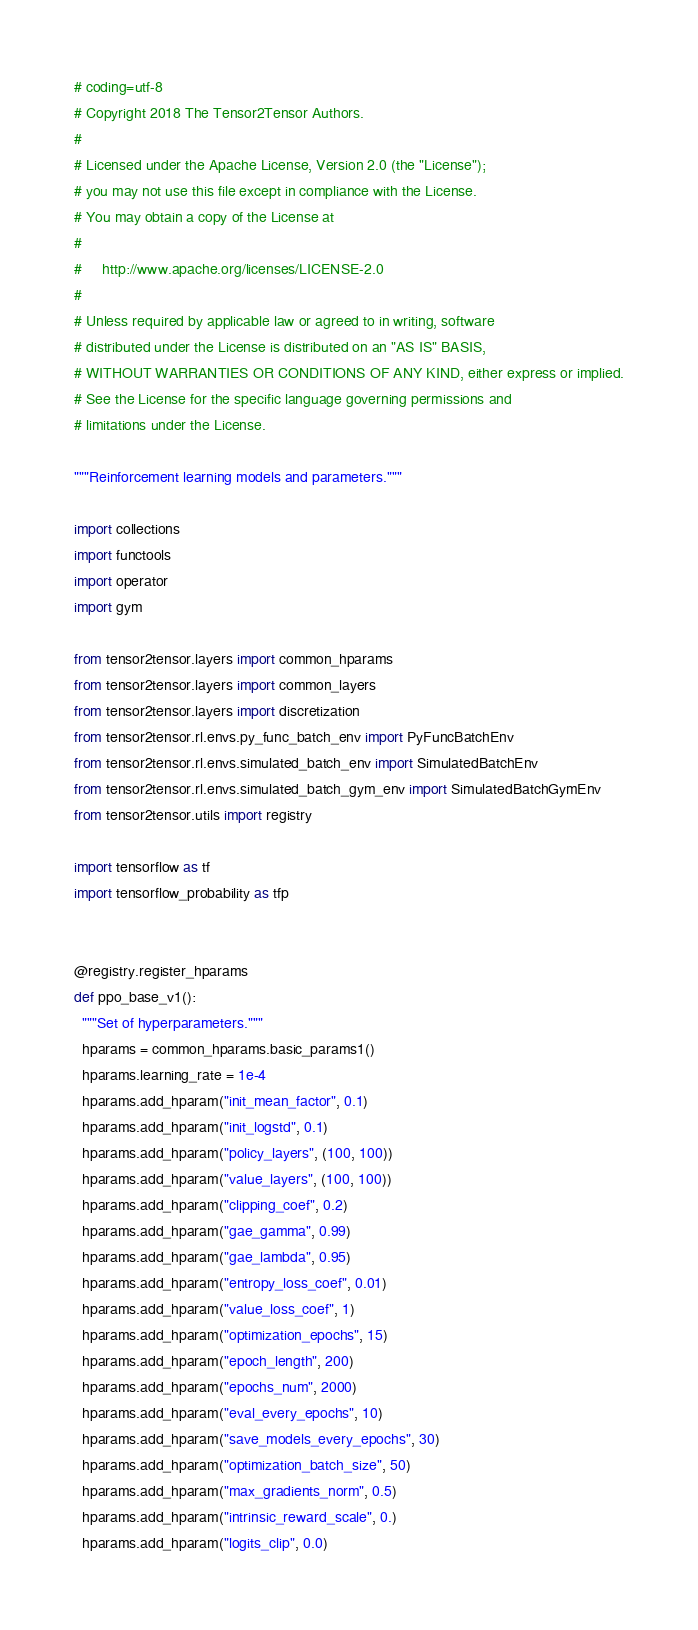Convert code to text. <code><loc_0><loc_0><loc_500><loc_500><_Python_># coding=utf-8
# Copyright 2018 The Tensor2Tensor Authors.
#
# Licensed under the Apache License, Version 2.0 (the "License");
# you may not use this file except in compliance with the License.
# You may obtain a copy of the License at
#
#     http://www.apache.org/licenses/LICENSE-2.0
#
# Unless required by applicable law or agreed to in writing, software
# distributed under the License is distributed on an "AS IS" BASIS,
# WITHOUT WARRANTIES OR CONDITIONS OF ANY KIND, either express or implied.
# See the License for the specific language governing permissions and
# limitations under the License.

"""Reinforcement learning models and parameters."""

import collections
import functools
import operator
import gym

from tensor2tensor.layers import common_hparams
from tensor2tensor.layers import common_layers
from tensor2tensor.layers import discretization
from tensor2tensor.rl.envs.py_func_batch_env import PyFuncBatchEnv
from tensor2tensor.rl.envs.simulated_batch_env import SimulatedBatchEnv
from tensor2tensor.rl.envs.simulated_batch_gym_env import SimulatedBatchGymEnv
from tensor2tensor.utils import registry

import tensorflow as tf
import tensorflow_probability as tfp


@registry.register_hparams
def ppo_base_v1():
  """Set of hyperparameters."""
  hparams = common_hparams.basic_params1()
  hparams.learning_rate = 1e-4
  hparams.add_hparam("init_mean_factor", 0.1)
  hparams.add_hparam("init_logstd", 0.1)
  hparams.add_hparam("policy_layers", (100, 100))
  hparams.add_hparam("value_layers", (100, 100))
  hparams.add_hparam("clipping_coef", 0.2)
  hparams.add_hparam("gae_gamma", 0.99)
  hparams.add_hparam("gae_lambda", 0.95)
  hparams.add_hparam("entropy_loss_coef", 0.01)
  hparams.add_hparam("value_loss_coef", 1)
  hparams.add_hparam("optimization_epochs", 15)
  hparams.add_hparam("epoch_length", 200)
  hparams.add_hparam("epochs_num", 2000)
  hparams.add_hparam("eval_every_epochs", 10)
  hparams.add_hparam("save_models_every_epochs", 30)
  hparams.add_hparam("optimization_batch_size", 50)
  hparams.add_hparam("max_gradients_norm", 0.5)
  hparams.add_hparam("intrinsic_reward_scale", 0.)
  hparams.add_hparam("logits_clip", 0.0)</code> 